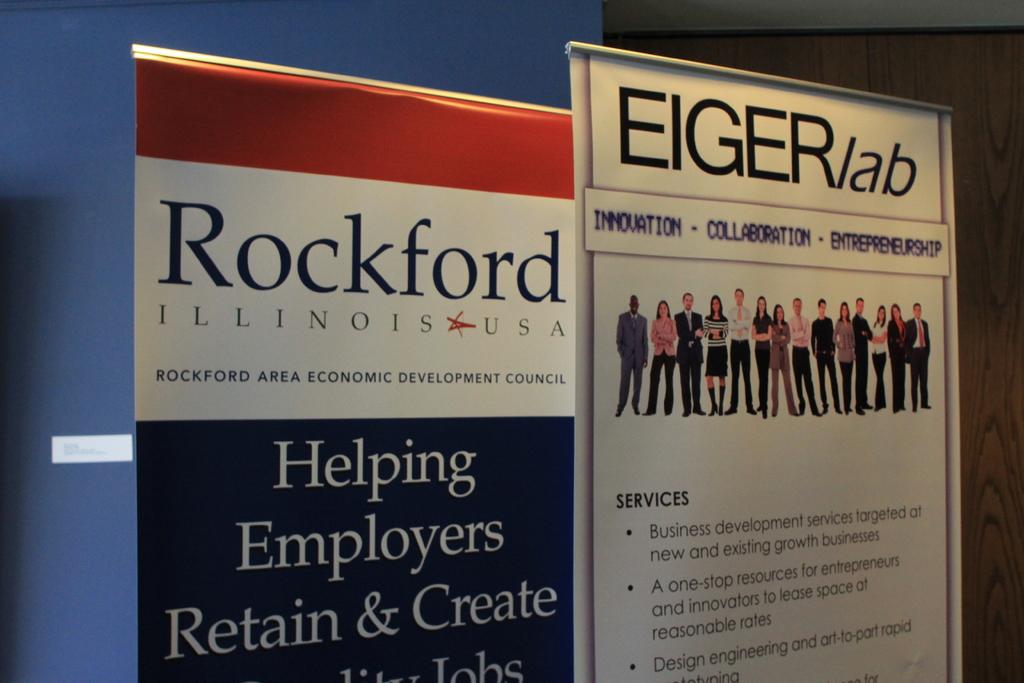What city and state is on the left?
Ensure brevity in your answer.  Rockford, illinois. 